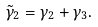<formula> <loc_0><loc_0><loc_500><loc_500>\tilde { \gamma } _ { 2 } = \gamma _ { 2 } + \gamma _ { 3 } .</formula> 